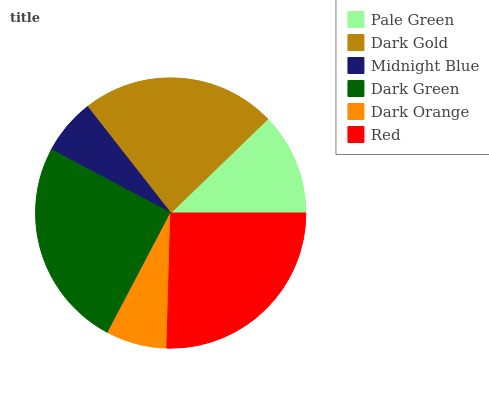Is Midnight Blue the minimum?
Answer yes or no. Yes. Is Red the maximum?
Answer yes or no. Yes. Is Dark Gold the minimum?
Answer yes or no. No. Is Dark Gold the maximum?
Answer yes or no. No. Is Dark Gold greater than Pale Green?
Answer yes or no. Yes. Is Pale Green less than Dark Gold?
Answer yes or no. Yes. Is Pale Green greater than Dark Gold?
Answer yes or no. No. Is Dark Gold less than Pale Green?
Answer yes or no. No. Is Dark Gold the high median?
Answer yes or no. Yes. Is Pale Green the low median?
Answer yes or no. Yes. Is Pale Green the high median?
Answer yes or no. No. Is Dark Gold the low median?
Answer yes or no. No. 